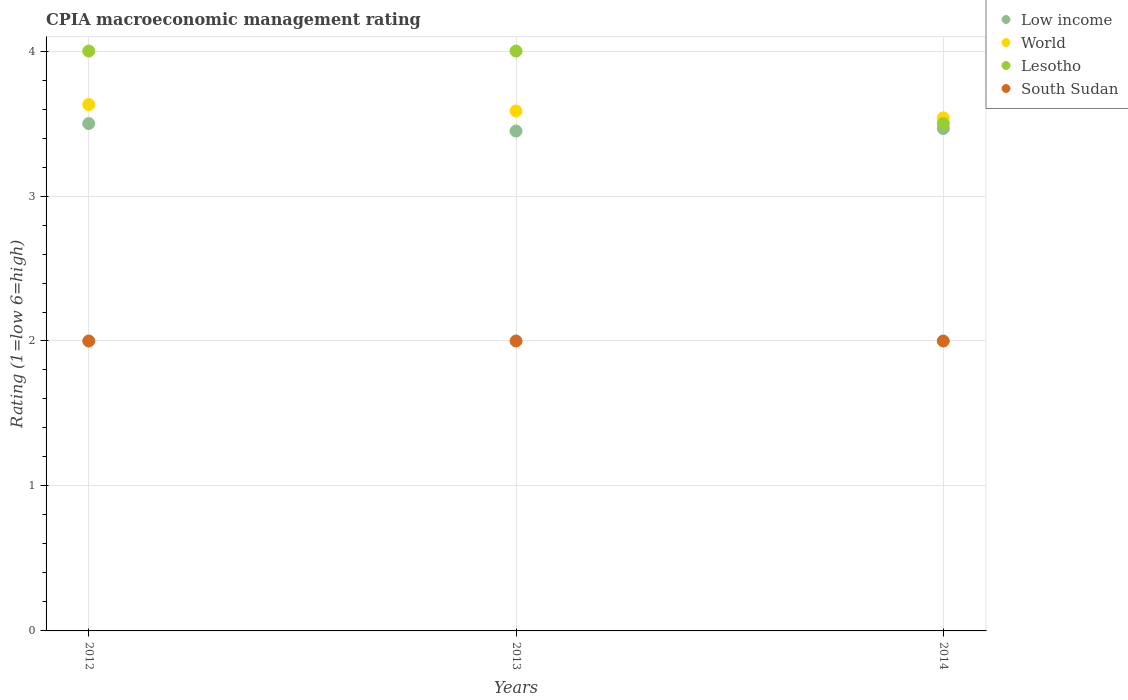How many different coloured dotlines are there?
Provide a succinct answer. 4. Is the number of dotlines equal to the number of legend labels?
Your answer should be very brief. Yes. What is the CPIA rating in Low income in 2014?
Your answer should be very brief. 3.47. Across all years, what is the maximum CPIA rating in World?
Offer a terse response. 3.63. Across all years, what is the minimum CPIA rating in World?
Your answer should be very brief. 3.54. In which year was the CPIA rating in South Sudan maximum?
Offer a very short reply. 2012. In which year was the CPIA rating in South Sudan minimum?
Your answer should be very brief. 2012. What is the total CPIA rating in Low income in the graph?
Your response must be concise. 10.41. What is the difference between the CPIA rating in Lesotho in 2013 and the CPIA rating in Low income in 2014?
Give a very brief answer. 0.53. What is the average CPIA rating in Lesotho per year?
Your answer should be very brief. 3.83. In the year 2014, what is the difference between the CPIA rating in Low income and CPIA rating in Lesotho?
Offer a very short reply. -0.03. In how many years, is the CPIA rating in Lesotho greater than 3?
Keep it short and to the point. 3. What is the ratio of the CPIA rating in World in 2012 to that in 2014?
Make the answer very short. 1.03. Is the difference between the CPIA rating in Low income in 2012 and 2013 greater than the difference between the CPIA rating in Lesotho in 2012 and 2013?
Your answer should be very brief. Yes. What is the difference between the highest and the second highest CPIA rating in South Sudan?
Your answer should be compact. 0. What is the difference between the highest and the lowest CPIA rating in Low income?
Offer a very short reply. 0.05. Is the sum of the CPIA rating in Low income in 2012 and 2013 greater than the maximum CPIA rating in South Sudan across all years?
Give a very brief answer. Yes. Is it the case that in every year, the sum of the CPIA rating in South Sudan and CPIA rating in Lesotho  is greater than the sum of CPIA rating in Low income and CPIA rating in World?
Provide a succinct answer. No. Is it the case that in every year, the sum of the CPIA rating in Lesotho and CPIA rating in South Sudan  is greater than the CPIA rating in World?
Your answer should be very brief. Yes. Does the CPIA rating in Lesotho monotonically increase over the years?
Keep it short and to the point. No. Is the CPIA rating in Lesotho strictly greater than the CPIA rating in South Sudan over the years?
Offer a terse response. Yes. How many dotlines are there?
Offer a very short reply. 4. What is the difference between two consecutive major ticks on the Y-axis?
Make the answer very short. 1. Are the values on the major ticks of Y-axis written in scientific E-notation?
Ensure brevity in your answer.  No. Does the graph contain grids?
Provide a short and direct response. Yes. How are the legend labels stacked?
Your answer should be very brief. Vertical. What is the title of the graph?
Offer a very short reply. CPIA macroeconomic management rating. Does "Zambia" appear as one of the legend labels in the graph?
Make the answer very short. No. What is the label or title of the Y-axis?
Provide a succinct answer. Rating (1=low 6=high). What is the Rating (1=low 6=high) in Low income in 2012?
Provide a short and direct response. 3.5. What is the Rating (1=low 6=high) of World in 2012?
Ensure brevity in your answer.  3.63. What is the Rating (1=low 6=high) of Lesotho in 2012?
Ensure brevity in your answer.  4. What is the Rating (1=low 6=high) of Low income in 2013?
Offer a terse response. 3.45. What is the Rating (1=low 6=high) of World in 2013?
Your answer should be compact. 3.59. What is the Rating (1=low 6=high) in South Sudan in 2013?
Make the answer very short. 2. What is the Rating (1=low 6=high) of Low income in 2014?
Your response must be concise. 3.47. What is the Rating (1=low 6=high) in World in 2014?
Make the answer very short. 3.54. What is the Rating (1=low 6=high) in Lesotho in 2014?
Offer a very short reply. 3.5. Across all years, what is the maximum Rating (1=low 6=high) in World?
Ensure brevity in your answer.  3.63. Across all years, what is the maximum Rating (1=low 6=high) of South Sudan?
Offer a terse response. 2. Across all years, what is the minimum Rating (1=low 6=high) of Low income?
Your answer should be very brief. 3.45. Across all years, what is the minimum Rating (1=low 6=high) in World?
Make the answer very short. 3.54. Across all years, what is the minimum Rating (1=low 6=high) of South Sudan?
Make the answer very short. 2. What is the total Rating (1=low 6=high) of Low income in the graph?
Your answer should be very brief. 10.41. What is the total Rating (1=low 6=high) in World in the graph?
Your response must be concise. 10.76. What is the total Rating (1=low 6=high) of South Sudan in the graph?
Give a very brief answer. 6. What is the difference between the Rating (1=low 6=high) in Low income in 2012 and that in 2013?
Offer a very short reply. 0.05. What is the difference between the Rating (1=low 6=high) in World in 2012 and that in 2013?
Make the answer very short. 0.04. What is the difference between the Rating (1=low 6=high) in Lesotho in 2012 and that in 2013?
Ensure brevity in your answer.  0. What is the difference between the Rating (1=low 6=high) of Low income in 2012 and that in 2014?
Make the answer very short. 0.03. What is the difference between the Rating (1=low 6=high) in World in 2012 and that in 2014?
Offer a very short reply. 0.09. What is the difference between the Rating (1=low 6=high) in Lesotho in 2012 and that in 2014?
Provide a succinct answer. 0.5. What is the difference between the Rating (1=low 6=high) in Low income in 2013 and that in 2014?
Provide a short and direct response. -0.02. What is the difference between the Rating (1=low 6=high) in World in 2013 and that in 2014?
Provide a succinct answer. 0.05. What is the difference between the Rating (1=low 6=high) of South Sudan in 2013 and that in 2014?
Give a very brief answer. 0. What is the difference between the Rating (1=low 6=high) in Low income in 2012 and the Rating (1=low 6=high) in World in 2013?
Your answer should be very brief. -0.09. What is the difference between the Rating (1=low 6=high) in World in 2012 and the Rating (1=low 6=high) in Lesotho in 2013?
Give a very brief answer. -0.37. What is the difference between the Rating (1=low 6=high) in World in 2012 and the Rating (1=low 6=high) in South Sudan in 2013?
Give a very brief answer. 1.63. What is the difference between the Rating (1=low 6=high) of Low income in 2012 and the Rating (1=low 6=high) of World in 2014?
Your answer should be very brief. -0.04. What is the difference between the Rating (1=low 6=high) in World in 2012 and the Rating (1=low 6=high) in Lesotho in 2014?
Ensure brevity in your answer.  0.13. What is the difference between the Rating (1=low 6=high) in World in 2012 and the Rating (1=low 6=high) in South Sudan in 2014?
Your response must be concise. 1.63. What is the difference between the Rating (1=low 6=high) of Lesotho in 2012 and the Rating (1=low 6=high) of South Sudan in 2014?
Offer a terse response. 2. What is the difference between the Rating (1=low 6=high) in Low income in 2013 and the Rating (1=low 6=high) in World in 2014?
Offer a terse response. -0.09. What is the difference between the Rating (1=low 6=high) in Low income in 2013 and the Rating (1=low 6=high) in Lesotho in 2014?
Make the answer very short. -0.05. What is the difference between the Rating (1=low 6=high) in Low income in 2013 and the Rating (1=low 6=high) in South Sudan in 2014?
Your answer should be very brief. 1.45. What is the difference between the Rating (1=low 6=high) of World in 2013 and the Rating (1=low 6=high) of Lesotho in 2014?
Offer a terse response. 0.09. What is the difference between the Rating (1=low 6=high) in World in 2013 and the Rating (1=low 6=high) in South Sudan in 2014?
Offer a very short reply. 1.59. What is the average Rating (1=low 6=high) of Low income per year?
Your answer should be very brief. 3.47. What is the average Rating (1=low 6=high) of World per year?
Your answer should be compact. 3.59. What is the average Rating (1=low 6=high) in Lesotho per year?
Keep it short and to the point. 3.83. What is the average Rating (1=low 6=high) of South Sudan per year?
Provide a succinct answer. 2. In the year 2012, what is the difference between the Rating (1=low 6=high) in Low income and Rating (1=low 6=high) in World?
Keep it short and to the point. -0.13. In the year 2012, what is the difference between the Rating (1=low 6=high) of Low income and Rating (1=low 6=high) of Lesotho?
Your response must be concise. -0.5. In the year 2012, what is the difference between the Rating (1=low 6=high) in World and Rating (1=low 6=high) in Lesotho?
Keep it short and to the point. -0.37. In the year 2012, what is the difference between the Rating (1=low 6=high) in World and Rating (1=low 6=high) in South Sudan?
Offer a terse response. 1.63. In the year 2013, what is the difference between the Rating (1=low 6=high) of Low income and Rating (1=low 6=high) of World?
Offer a very short reply. -0.14. In the year 2013, what is the difference between the Rating (1=low 6=high) in Low income and Rating (1=low 6=high) in Lesotho?
Give a very brief answer. -0.55. In the year 2013, what is the difference between the Rating (1=low 6=high) of Low income and Rating (1=low 6=high) of South Sudan?
Ensure brevity in your answer.  1.45. In the year 2013, what is the difference between the Rating (1=low 6=high) of World and Rating (1=low 6=high) of Lesotho?
Your answer should be compact. -0.41. In the year 2013, what is the difference between the Rating (1=low 6=high) of World and Rating (1=low 6=high) of South Sudan?
Ensure brevity in your answer.  1.59. In the year 2014, what is the difference between the Rating (1=low 6=high) of Low income and Rating (1=low 6=high) of World?
Your answer should be very brief. -0.07. In the year 2014, what is the difference between the Rating (1=low 6=high) of Low income and Rating (1=low 6=high) of Lesotho?
Your answer should be very brief. -0.03. In the year 2014, what is the difference between the Rating (1=low 6=high) of Low income and Rating (1=low 6=high) of South Sudan?
Offer a very short reply. 1.47. In the year 2014, what is the difference between the Rating (1=low 6=high) of World and Rating (1=low 6=high) of Lesotho?
Your answer should be very brief. 0.04. In the year 2014, what is the difference between the Rating (1=low 6=high) of World and Rating (1=low 6=high) of South Sudan?
Provide a short and direct response. 1.54. In the year 2014, what is the difference between the Rating (1=low 6=high) in Lesotho and Rating (1=low 6=high) in South Sudan?
Give a very brief answer. 1.5. What is the ratio of the Rating (1=low 6=high) in Low income in 2012 to that in 2013?
Ensure brevity in your answer.  1.01. What is the ratio of the Rating (1=low 6=high) of World in 2012 to that in 2013?
Your answer should be compact. 1.01. What is the ratio of the Rating (1=low 6=high) in World in 2012 to that in 2014?
Give a very brief answer. 1.03. What is the ratio of the Rating (1=low 6=high) of Lesotho in 2012 to that in 2014?
Keep it short and to the point. 1.14. What is the ratio of the Rating (1=low 6=high) in Low income in 2013 to that in 2014?
Give a very brief answer. 0.99. What is the ratio of the Rating (1=low 6=high) in World in 2013 to that in 2014?
Make the answer very short. 1.01. What is the ratio of the Rating (1=low 6=high) in South Sudan in 2013 to that in 2014?
Your answer should be compact. 1. What is the difference between the highest and the second highest Rating (1=low 6=high) in Low income?
Provide a short and direct response. 0.03. What is the difference between the highest and the second highest Rating (1=low 6=high) in World?
Ensure brevity in your answer.  0.04. What is the difference between the highest and the lowest Rating (1=low 6=high) in Low income?
Give a very brief answer. 0.05. What is the difference between the highest and the lowest Rating (1=low 6=high) in World?
Offer a terse response. 0.09. What is the difference between the highest and the lowest Rating (1=low 6=high) of South Sudan?
Provide a short and direct response. 0. 